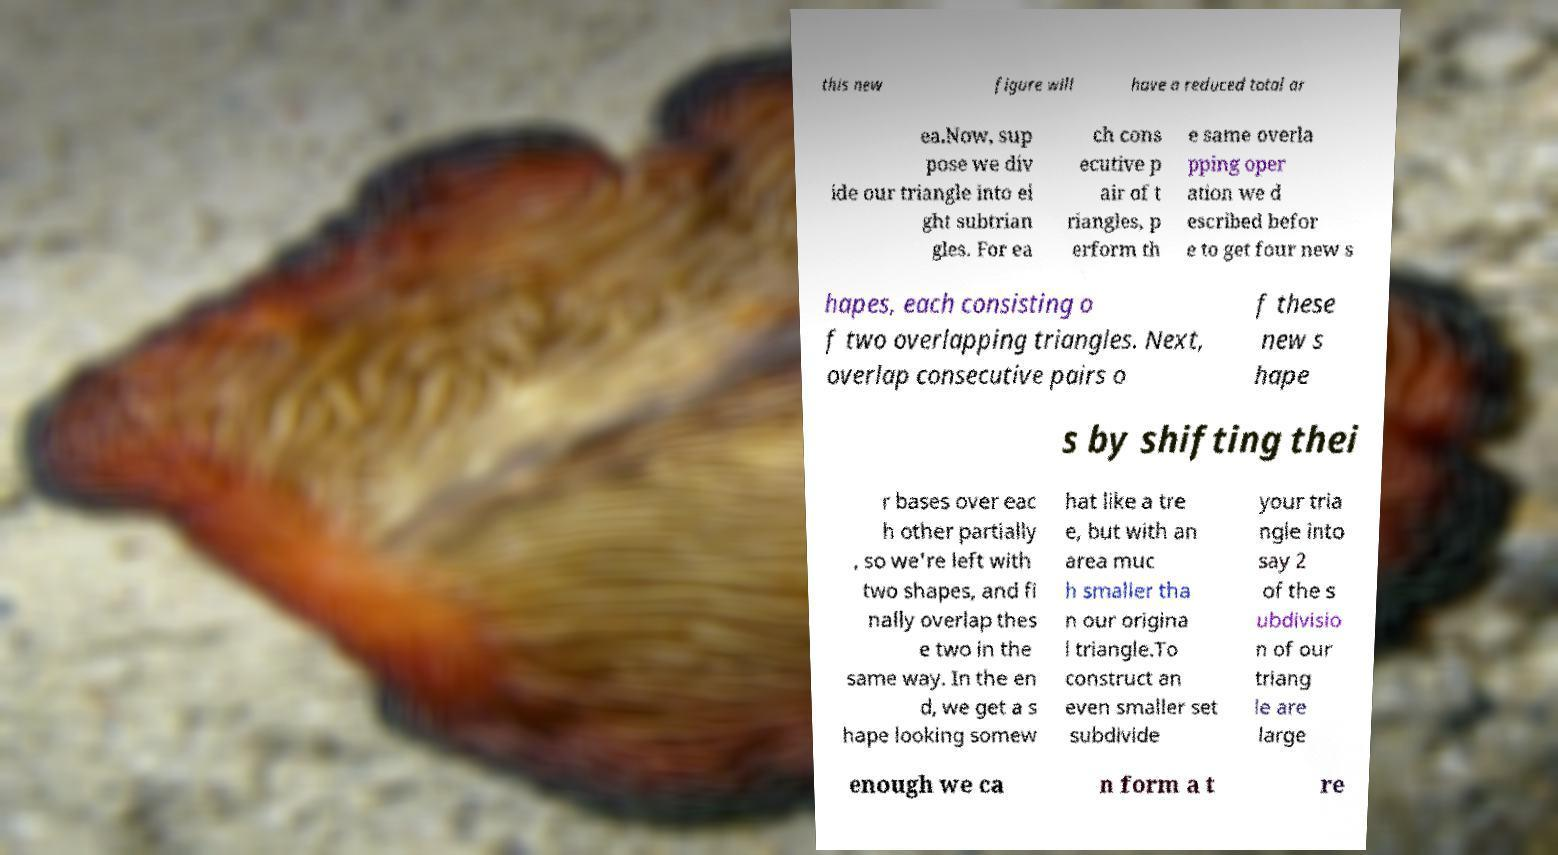For documentation purposes, I need the text within this image transcribed. Could you provide that? this new figure will have a reduced total ar ea.Now, sup pose we div ide our triangle into ei ght subtrian gles. For ea ch cons ecutive p air of t riangles, p erform th e same overla pping oper ation we d escribed befor e to get four new s hapes, each consisting o f two overlapping triangles. Next, overlap consecutive pairs o f these new s hape s by shifting thei r bases over eac h other partially , so we're left with two shapes, and fi nally overlap thes e two in the same way. In the en d, we get a s hape looking somew hat like a tre e, but with an area muc h smaller tha n our origina l triangle.To construct an even smaller set subdivide your tria ngle into say 2 of the s ubdivisio n of our triang le are large enough we ca n form a t re 